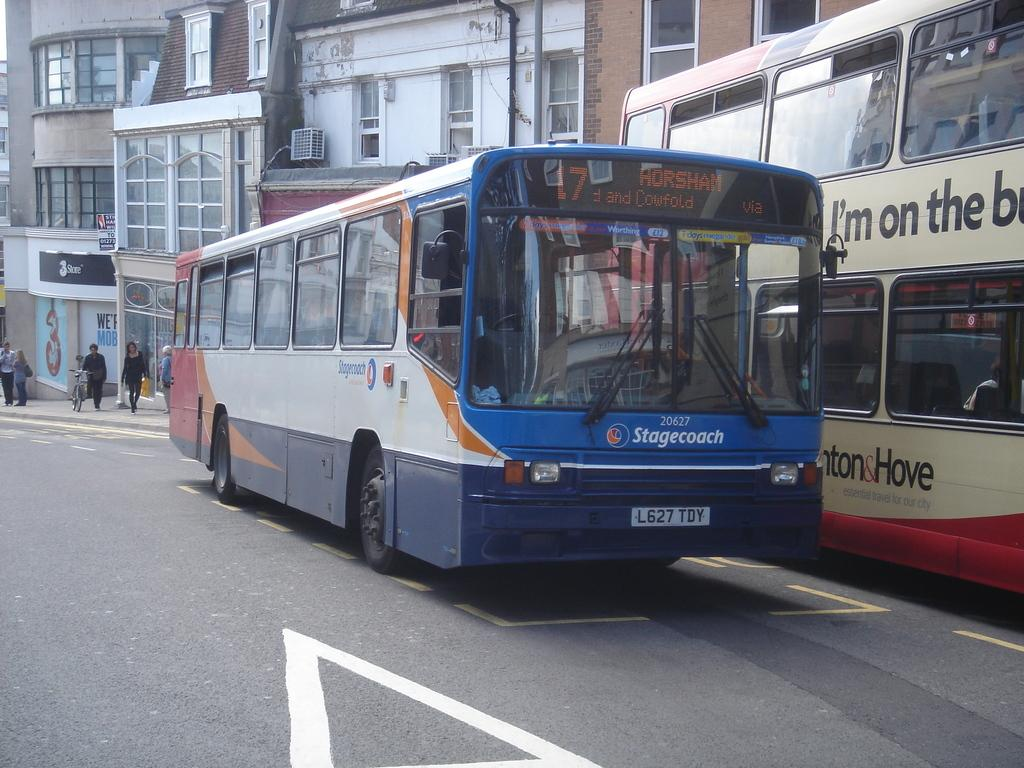<image>
Write a terse but informative summary of the picture. A Stagecoach bus with number 20627 is going to Horsham. 